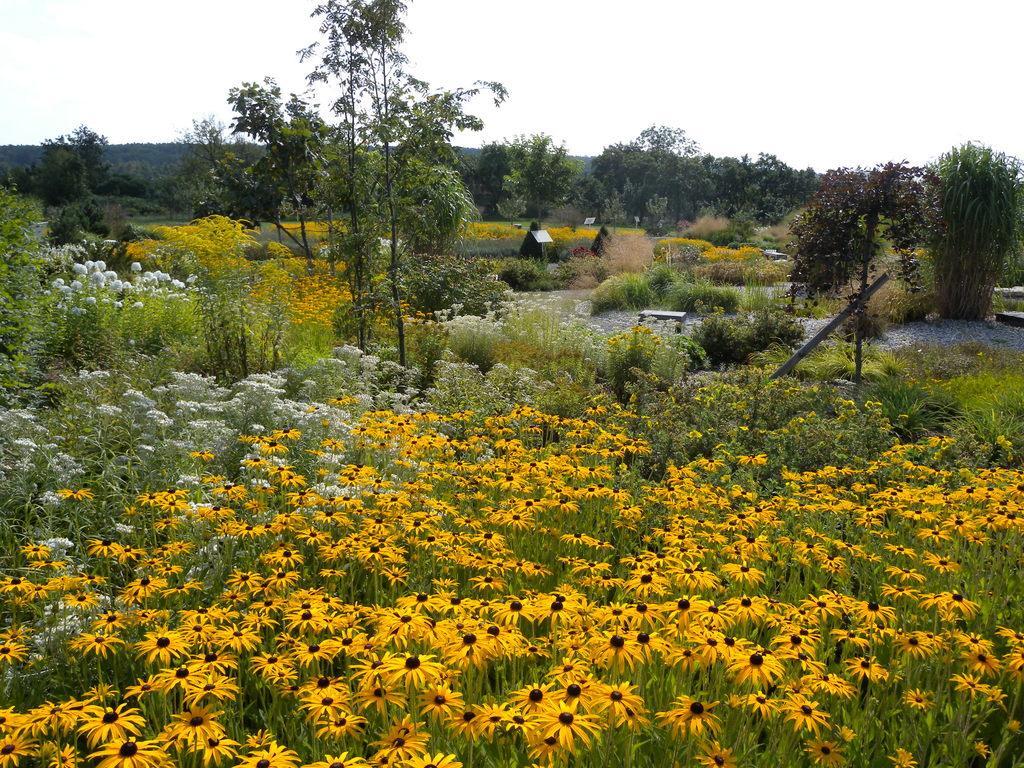How would you summarize this image in a sentence or two? In this picture there are flower field at the bottom side of the image and there are boards and trees in the background area of the image. 